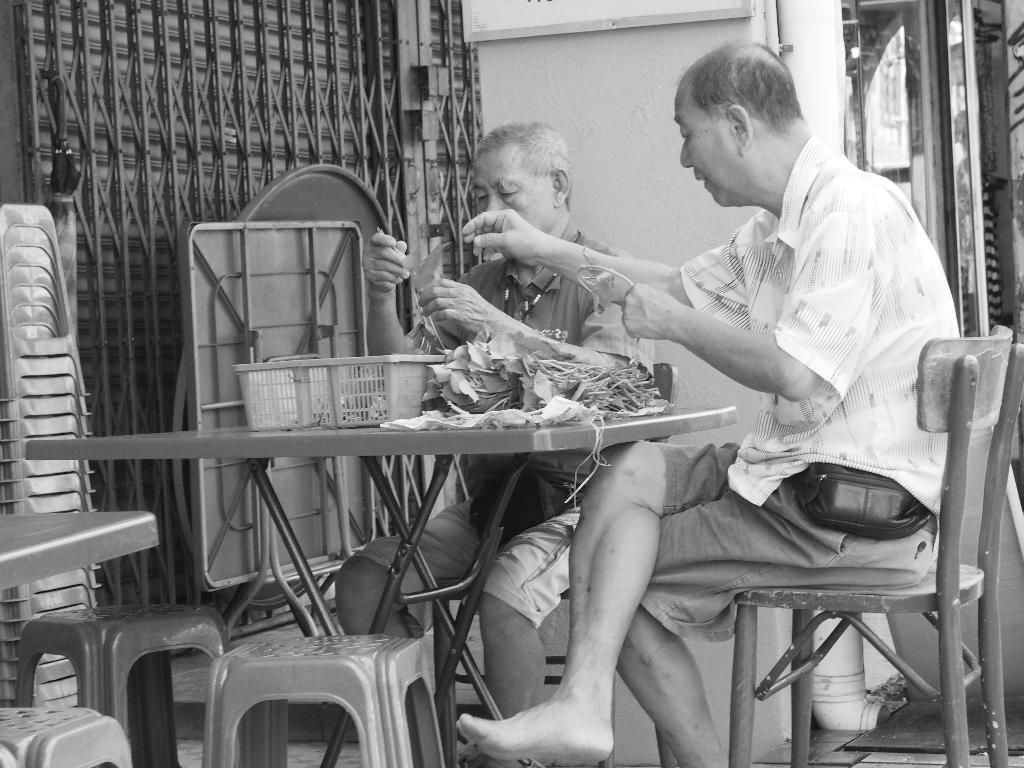Please provide a concise description of this image. To the right side there is a man with white shirt is sitting on the chair. He is wearing a bag around his waist. Beside him there is another man sitting. In front of them there is a table with some leaves and basket on it. And to the left side bottom there are 3 stools. And in the left side there are some stools. We can see a grilled gate. To the right side corner there is a door. 